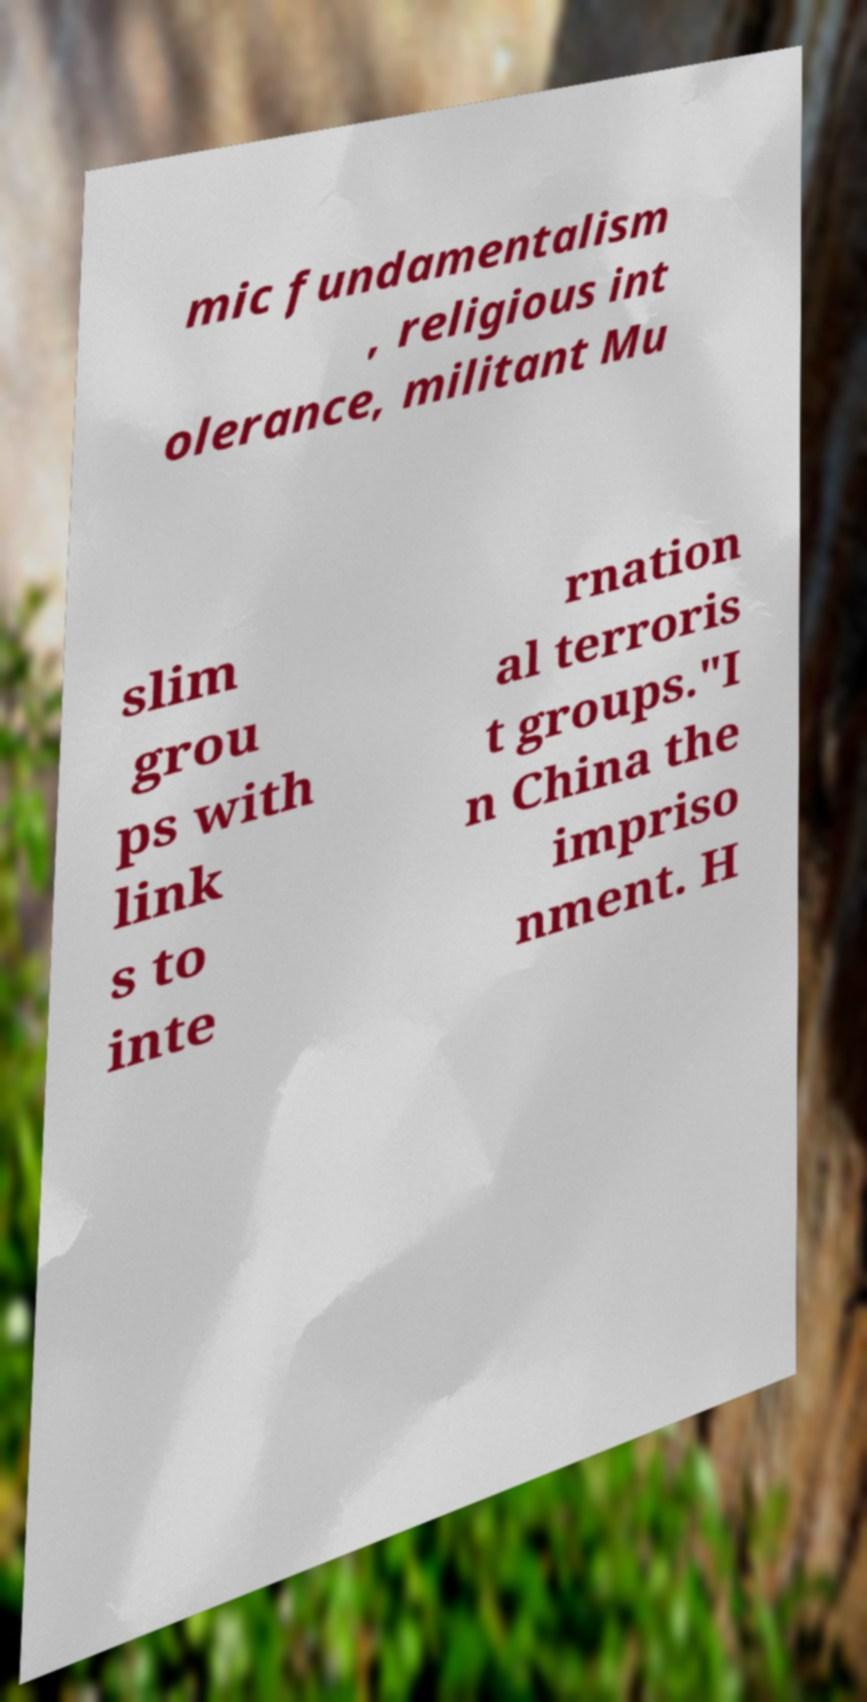Can you accurately transcribe the text from the provided image for me? mic fundamentalism , religious int olerance, militant Mu slim grou ps with link s to inte rnation al terroris t groups."I n China the impriso nment. H 